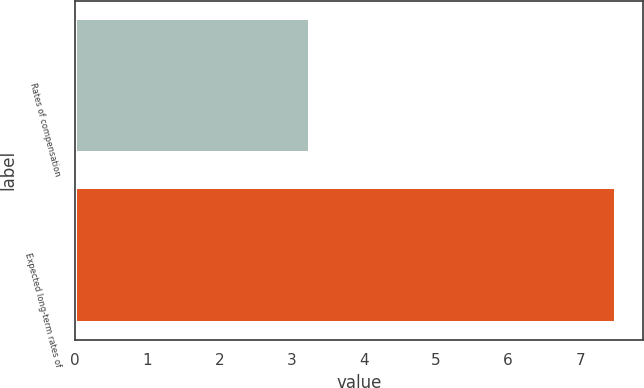<chart> <loc_0><loc_0><loc_500><loc_500><bar_chart><fcel>Rates of compensation<fcel>Expected long-term rates of<nl><fcel>3.25<fcel>7.5<nl></chart> 